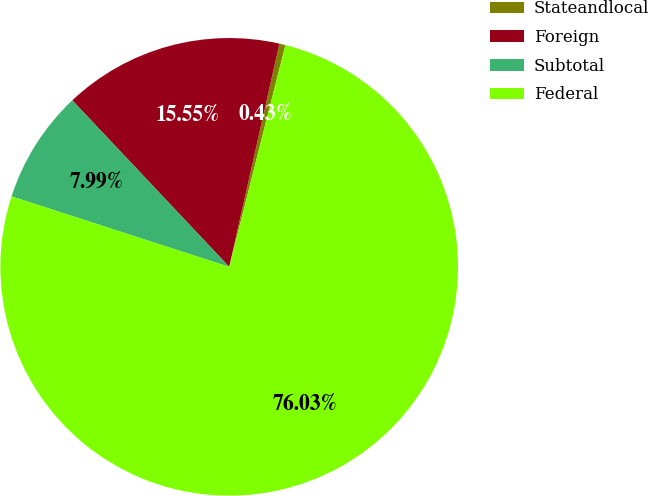<chart> <loc_0><loc_0><loc_500><loc_500><pie_chart><fcel>Stateandlocal<fcel>Foreign<fcel>Subtotal<fcel>Federal<nl><fcel>0.43%<fcel>15.55%<fcel>7.99%<fcel>76.04%<nl></chart> 